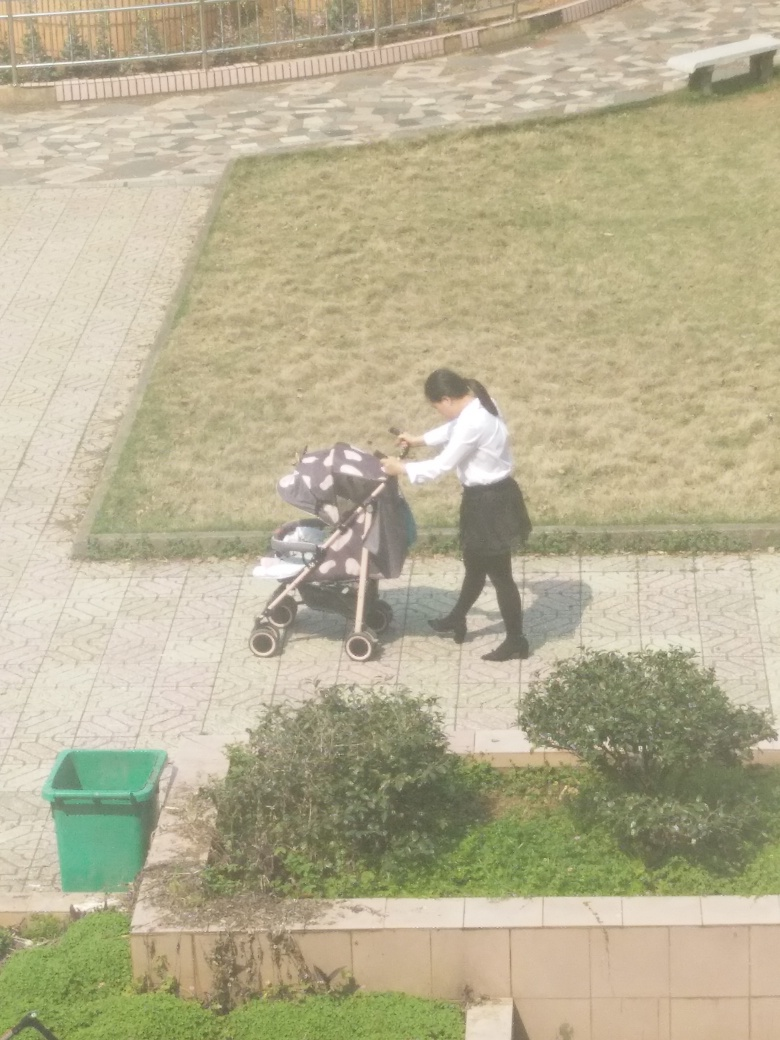What might be the reason for someone to push an empty stroller? There could be several reasons for pushing an empty stroller. The person might be on their way to pick up a child or returning home after dropping a child off elsewhere. Alternatively, they could be transporting items inside the stroller or simply moving it from one location to another. 